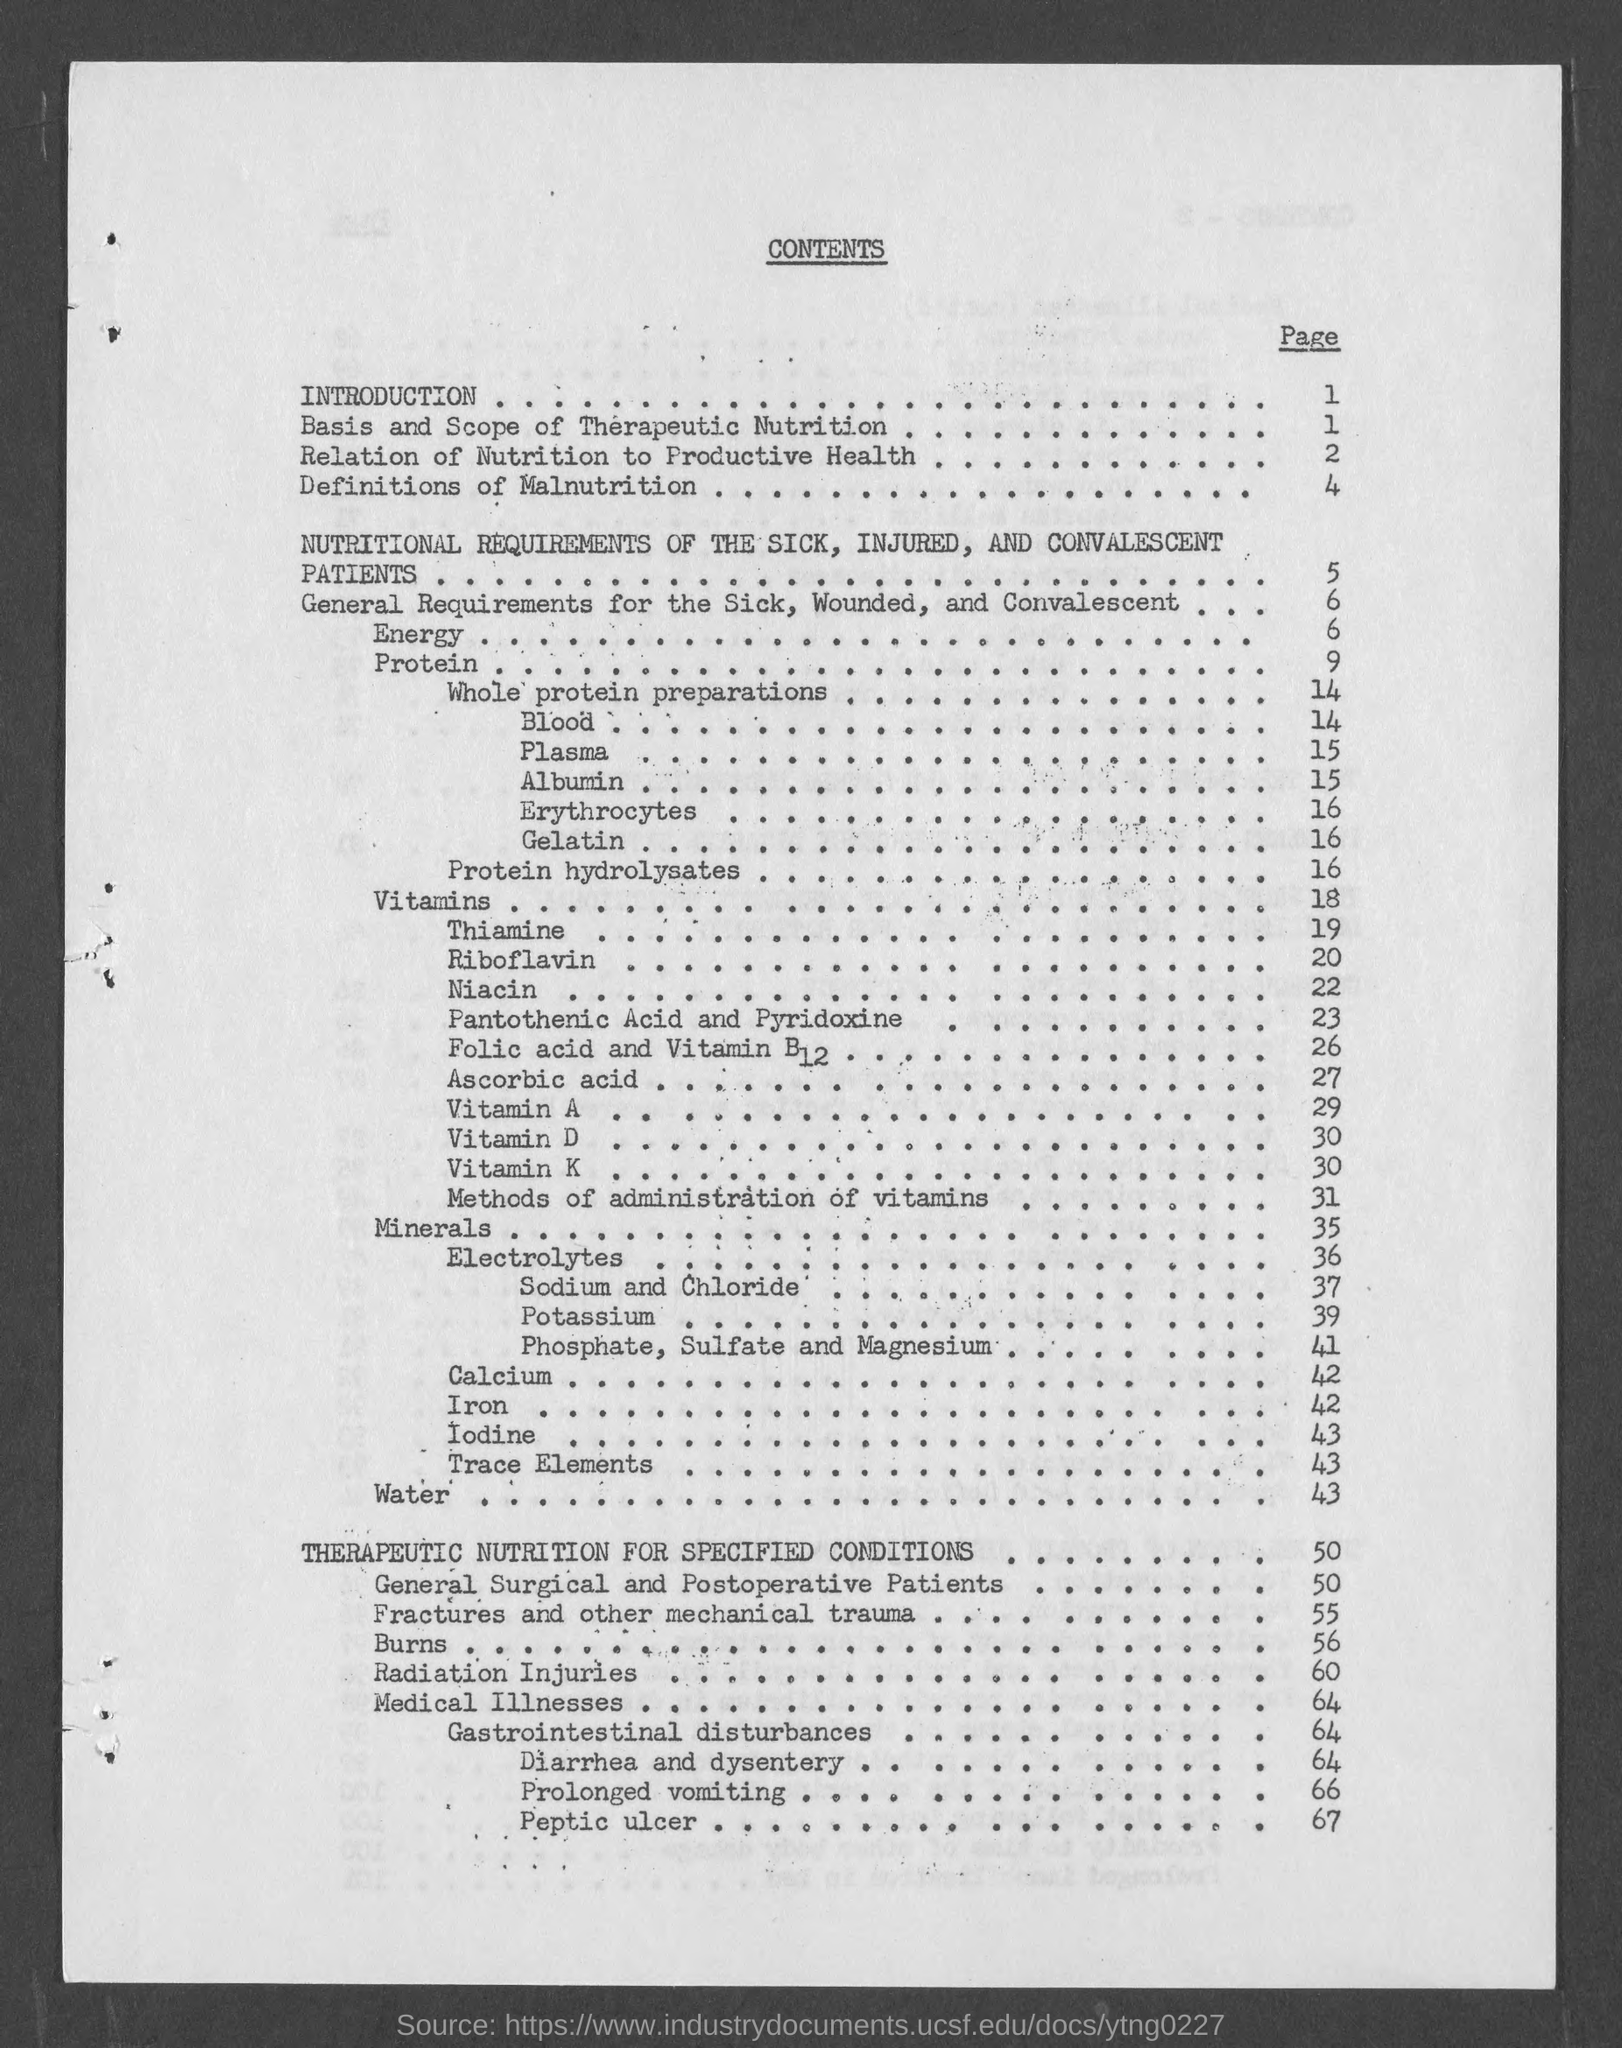Outline some significant characteristics in this image. The page number for Gelatin is 16. The page number for Prolonged Vomiting is 66. The page number for Whole Protein preparations is 14. The page number for the introduction is 1. The page number for Erythrocytes is 16. 